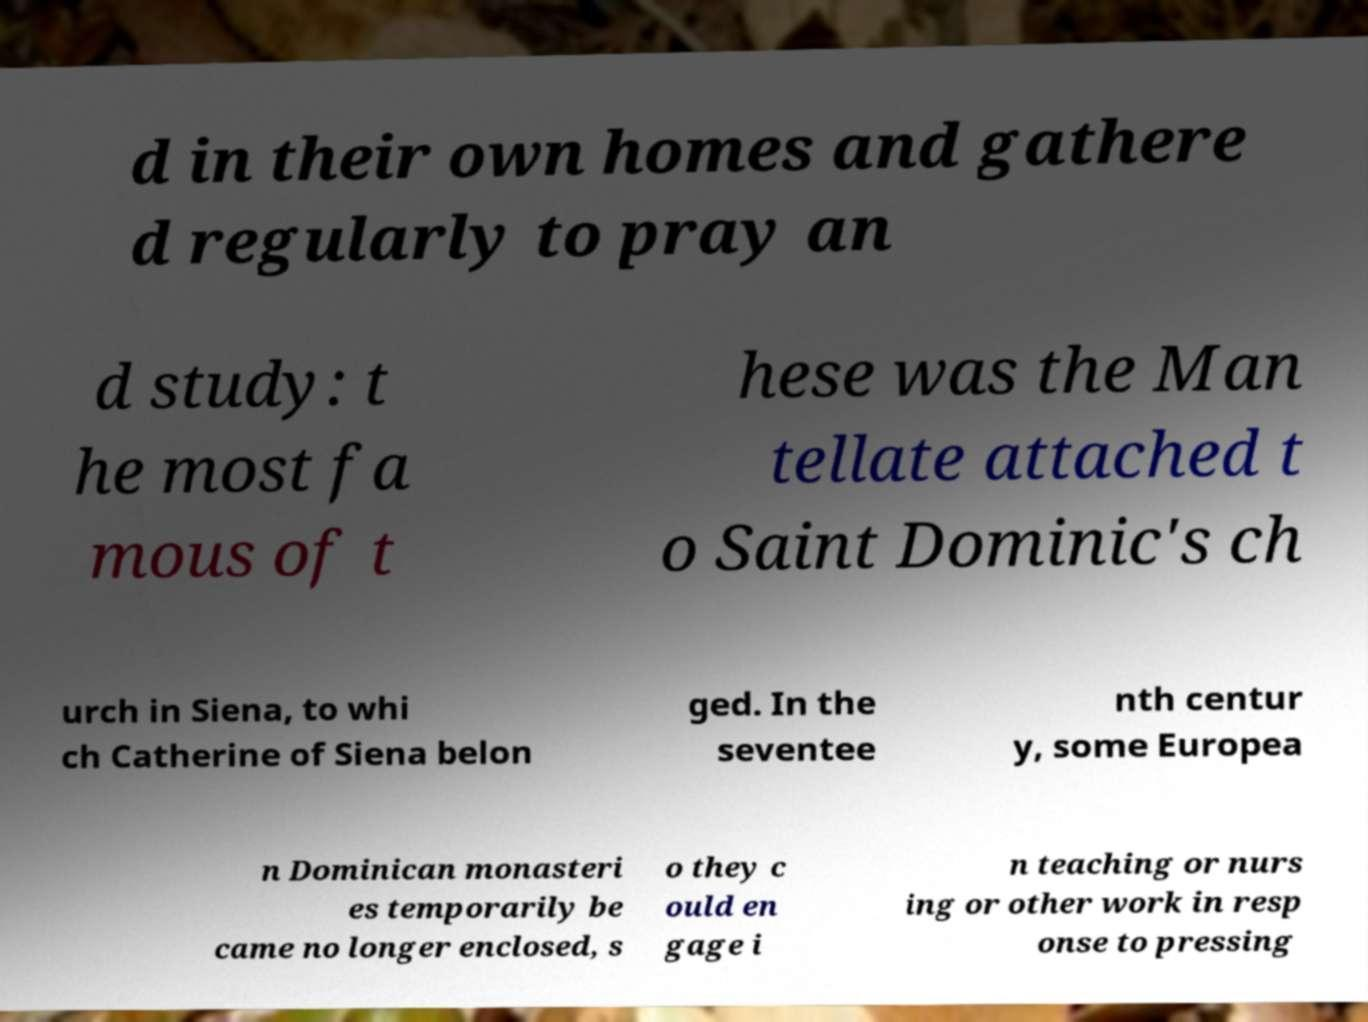Can you accurately transcribe the text from the provided image for me? d in their own homes and gathere d regularly to pray an d study: t he most fa mous of t hese was the Man tellate attached t o Saint Dominic's ch urch in Siena, to whi ch Catherine of Siena belon ged. In the seventee nth centur y, some Europea n Dominican monasteri es temporarily be came no longer enclosed, s o they c ould en gage i n teaching or nurs ing or other work in resp onse to pressing 